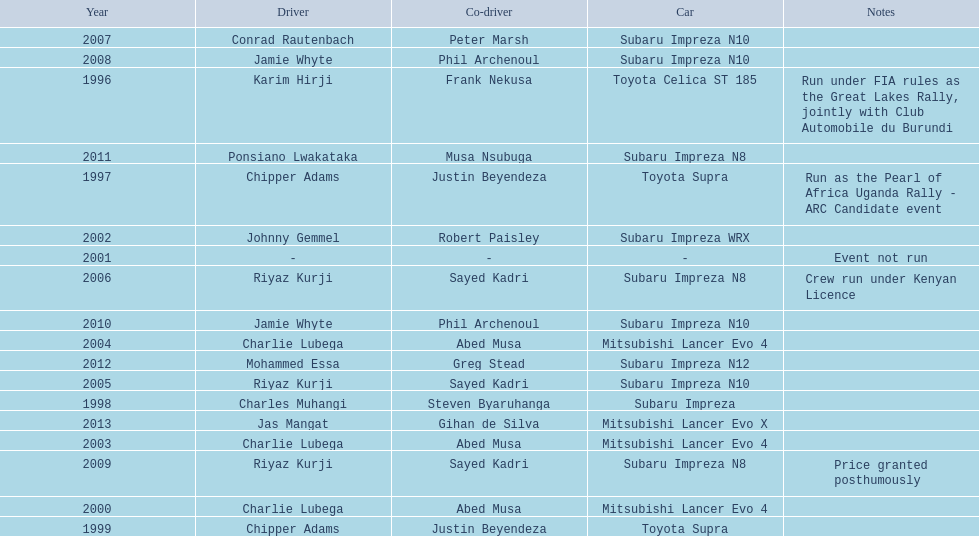How many drivers won at least twice? 4. 